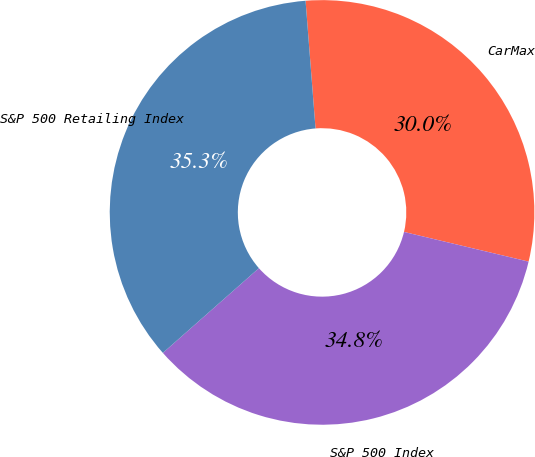<chart> <loc_0><loc_0><loc_500><loc_500><pie_chart><fcel>CarMax<fcel>S&P 500 Index<fcel>S&P 500 Retailing Index<nl><fcel>29.96%<fcel>34.77%<fcel>35.27%<nl></chart> 